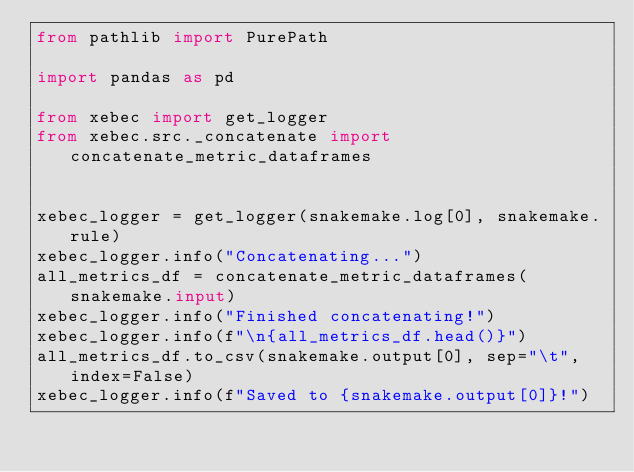<code> <loc_0><loc_0><loc_500><loc_500><_Python_>from pathlib import PurePath

import pandas as pd

from xebec import get_logger
from xebec.src._concatenate import concatenate_metric_dataframes


xebec_logger = get_logger(snakemake.log[0], snakemake.rule)
xebec_logger.info("Concatenating...")
all_metrics_df = concatenate_metric_dataframes(snakemake.input)
xebec_logger.info("Finished concatenating!")
xebec_logger.info(f"\n{all_metrics_df.head()}")
all_metrics_df.to_csv(snakemake.output[0], sep="\t", index=False)
xebec_logger.info(f"Saved to {snakemake.output[0]}!")
</code> 